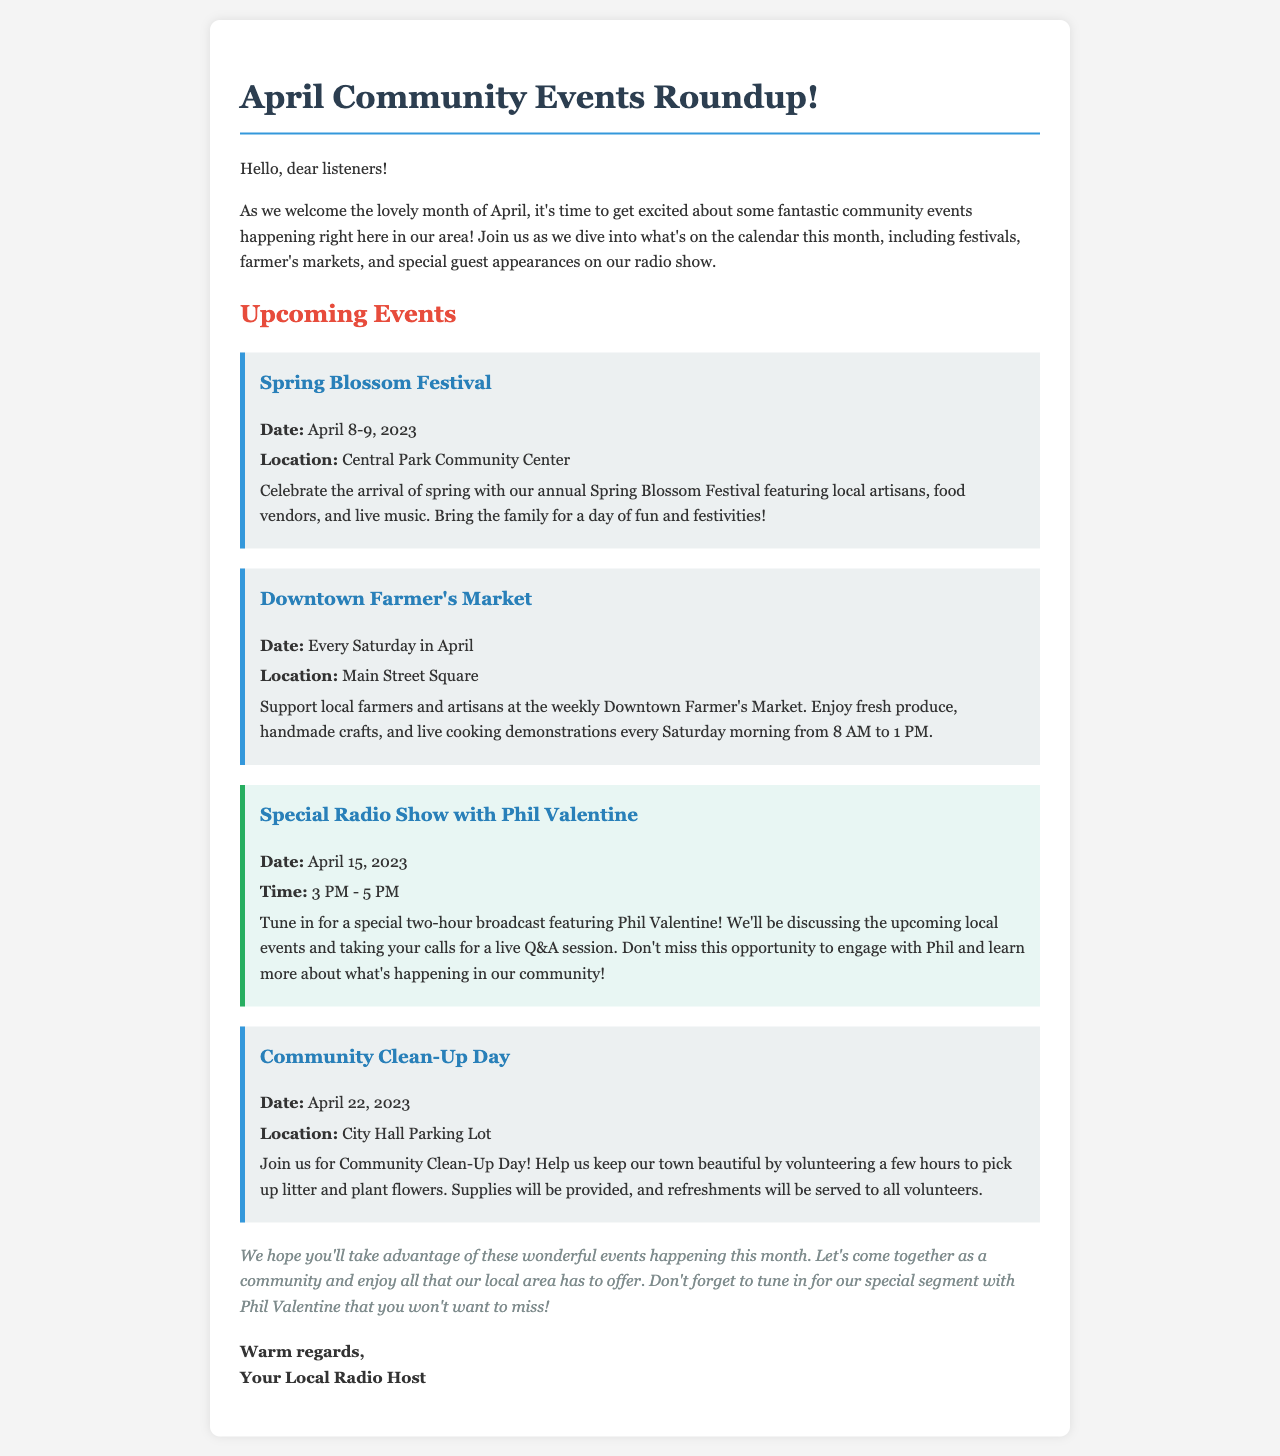What is the name of the festival happening on April 8-9? The festival mentioned is the Spring Blossom Festival.
Answer: Spring Blossom Festival Where is the Downtown Farmer's Market located? The location of the Downtown Farmer's Market is Main Street Square.
Answer: Main Street Square What date is the special radio show with Phil Valentine? The document states that the special radio show is on April 15, 2023.
Answer: April 15, 2023 How long will the special radio show with Phil Valentine last? The show is scheduled for a two-hour broadcast from 3 PM to 5 PM.
Answer: two hours What activity is planned for Community Clean-Up Day? The event involves picking up litter and planting flowers in the community.
Answer: picking up litter and planting flowers How frequently does the Downtown Farmer's Market occur? The market takes place every Saturday in April.
Answer: Every Saturday What type of refreshments will be provided to volunteers during Community Clean-Up Day? The document specifies that refreshments will be served to all volunteers.
Answer: Refreshments What is the purpose of the special segment with Phil Valentine? The segment aims to discuss upcoming local events and engage with listeners through a Q&A session.
Answer: Discuss upcoming local events and Q&A session 